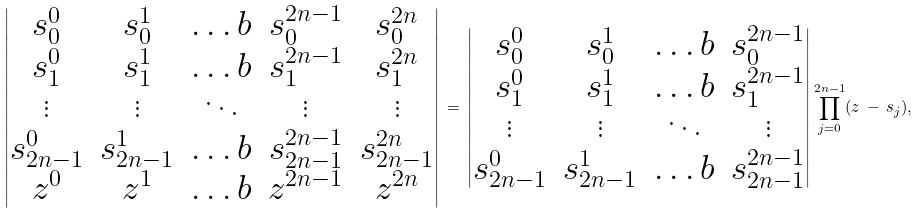<formula> <loc_0><loc_0><loc_500><loc_500>\begin{vmatrix} s _ { 0 } ^ { 0 } & s _ { 0 } ^ { 1 } & \dots b & s _ { 0 } ^ { 2 n - 1 } & s _ { 0 } ^ { 2 n } \\ s _ { 1 } ^ { 0 } & s _ { 1 } ^ { 1 } & \dots b & s _ { 1 } ^ { 2 n - 1 } & s _ { 1 } ^ { 2 n } \\ \vdots & \vdots & \ddots & \vdots & \vdots \\ s _ { 2 n - 1 } ^ { 0 } & s _ { 2 n - 1 } ^ { 1 } & \dots b & s _ { 2 n - 1 } ^ { 2 n - 1 } & s _ { 2 n - 1 } ^ { 2 n } \\ z ^ { 0 } & z ^ { 1 } & \dots b & z ^ { 2 n - 1 } & z ^ { 2 n } \end{vmatrix} \, = \, \begin{vmatrix} s _ { 0 } ^ { 0 } & s _ { 0 } ^ { 1 } & \dots b & s _ { 0 } ^ { 2 n - 1 } \\ s _ { 1 } ^ { 0 } & s _ { 1 } ^ { 1 } & \dots b & s _ { 1 } ^ { 2 n - 1 } \\ \vdots & \vdots & \ddots & \vdots \\ s _ { 2 n - 1 } ^ { 0 } & s _ { 2 n - 1 } ^ { 1 } & \dots b & s _ { 2 n - 1 } ^ { 2 n - 1 } \end{vmatrix} \prod _ { j = 0 } ^ { 2 n - 1 } ( z \, - \, s _ { j } ) ,</formula> 